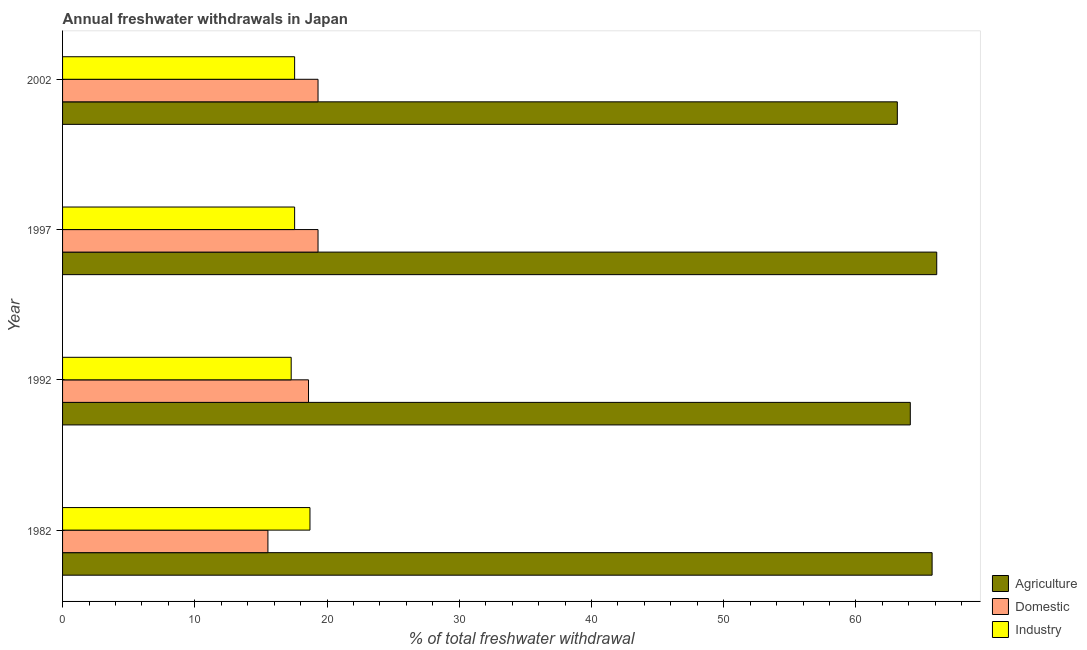How many different coloured bars are there?
Offer a very short reply. 3. How many groups of bars are there?
Your response must be concise. 4. How many bars are there on the 2nd tick from the bottom?
Ensure brevity in your answer.  3. What is the label of the 3rd group of bars from the top?
Provide a short and direct response. 1992. In how many cases, is the number of bars for a given year not equal to the number of legend labels?
Offer a terse response. 0. What is the percentage of freshwater withdrawal for domestic purposes in 2002?
Your response must be concise. 19.32. Across all years, what is the maximum percentage of freshwater withdrawal for domestic purposes?
Your answer should be compact. 19.32. Across all years, what is the minimum percentage of freshwater withdrawal for agriculture?
Ensure brevity in your answer.  63.13. In which year was the percentage of freshwater withdrawal for domestic purposes maximum?
Ensure brevity in your answer.  1997. In which year was the percentage of freshwater withdrawal for agriculture minimum?
Your answer should be compact. 2002. What is the total percentage of freshwater withdrawal for agriculture in the graph?
Keep it short and to the point. 259.11. What is the difference between the percentage of freshwater withdrawal for domestic purposes in 1982 and that in 1997?
Provide a short and direct response. -3.79. What is the difference between the percentage of freshwater withdrawal for domestic purposes in 1992 and the percentage of freshwater withdrawal for industry in 2002?
Provide a short and direct response. 1.05. What is the average percentage of freshwater withdrawal for industry per year?
Offer a very short reply. 17.77. In the year 1997, what is the difference between the percentage of freshwater withdrawal for domestic purposes and percentage of freshwater withdrawal for agriculture?
Give a very brief answer. -46.79. In how many years, is the percentage of freshwater withdrawal for industry greater than 60 %?
Make the answer very short. 0. What is the ratio of the percentage of freshwater withdrawal for domestic purposes in 1992 to that in 2002?
Offer a terse response. 0.96. Is the difference between the percentage of freshwater withdrawal for agriculture in 1992 and 2002 greater than the difference between the percentage of freshwater withdrawal for industry in 1992 and 2002?
Your answer should be very brief. Yes. What is the difference between the highest and the second highest percentage of freshwater withdrawal for domestic purposes?
Offer a terse response. 0. What is the difference between the highest and the lowest percentage of freshwater withdrawal for industry?
Your answer should be very brief. 1.42. In how many years, is the percentage of freshwater withdrawal for agriculture greater than the average percentage of freshwater withdrawal for agriculture taken over all years?
Your response must be concise. 2. What does the 3rd bar from the top in 1982 represents?
Offer a terse response. Agriculture. What does the 2nd bar from the bottom in 1982 represents?
Your answer should be compact. Domestic. How many bars are there?
Make the answer very short. 12. How many years are there in the graph?
Keep it short and to the point. 4. Are the values on the major ticks of X-axis written in scientific E-notation?
Your answer should be very brief. No. What is the title of the graph?
Provide a short and direct response. Annual freshwater withdrawals in Japan. What is the label or title of the X-axis?
Offer a very short reply. % of total freshwater withdrawal. What is the label or title of the Y-axis?
Your response must be concise. Year. What is the % of total freshwater withdrawal in Agriculture in 1982?
Make the answer very short. 65.76. What is the % of total freshwater withdrawal in Domestic in 1982?
Your answer should be very brief. 15.53. What is the % of total freshwater withdrawal in Industry in 1982?
Offer a terse response. 18.71. What is the % of total freshwater withdrawal of Agriculture in 1992?
Offer a terse response. 64.11. What is the % of total freshwater withdrawal of Domestic in 1992?
Keep it short and to the point. 18.6. What is the % of total freshwater withdrawal in Industry in 1992?
Your answer should be compact. 17.29. What is the % of total freshwater withdrawal of Agriculture in 1997?
Provide a short and direct response. 66.11. What is the % of total freshwater withdrawal in Domestic in 1997?
Offer a very short reply. 19.32. What is the % of total freshwater withdrawal in Industry in 1997?
Make the answer very short. 17.55. What is the % of total freshwater withdrawal in Agriculture in 2002?
Offer a terse response. 63.13. What is the % of total freshwater withdrawal of Domestic in 2002?
Keep it short and to the point. 19.32. What is the % of total freshwater withdrawal in Industry in 2002?
Your response must be concise. 17.55. Across all years, what is the maximum % of total freshwater withdrawal of Agriculture?
Offer a very short reply. 66.11. Across all years, what is the maximum % of total freshwater withdrawal of Domestic?
Provide a succinct answer. 19.32. Across all years, what is the maximum % of total freshwater withdrawal of Industry?
Keep it short and to the point. 18.71. Across all years, what is the minimum % of total freshwater withdrawal in Agriculture?
Give a very brief answer. 63.13. Across all years, what is the minimum % of total freshwater withdrawal in Domestic?
Keep it short and to the point. 15.53. Across all years, what is the minimum % of total freshwater withdrawal in Industry?
Offer a very short reply. 17.29. What is the total % of total freshwater withdrawal in Agriculture in the graph?
Your answer should be compact. 259.11. What is the total % of total freshwater withdrawal in Domestic in the graph?
Keep it short and to the point. 72.77. What is the total % of total freshwater withdrawal in Industry in the graph?
Provide a short and direct response. 71.1. What is the difference between the % of total freshwater withdrawal in Agriculture in 1982 and that in 1992?
Provide a succinct answer. 1.65. What is the difference between the % of total freshwater withdrawal of Domestic in 1982 and that in 1992?
Provide a succinct answer. -3.07. What is the difference between the % of total freshwater withdrawal of Industry in 1982 and that in 1992?
Your answer should be compact. 1.42. What is the difference between the % of total freshwater withdrawal of Agriculture in 1982 and that in 1997?
Make the answer very short. -0.35. What is the difference between the % of total freshwater withdrawal in Domestic in 1982 and that in 1997?
Provide a short and direct response. -3.79. What is the difference between the % of total freshwater withdrawal in Industry in 1982 and that in 1997?
Your response must be concise. 1.16. What is the difference between the % of total freshwater withdrawal of Agriculture in 1982 and that in 2002?
Ensure brevity in your answer.  2.63. What is the difference between the % of total freshwater withdrawal in Domestic in 1982 and that in 2002?
Offer a terse response. -3.79. What is the difference between the % of total freshwater withdrawal of Industry in 1982 and that in 2002?
Provide a short and direct response. 1.16. What is the difference between the % of total freshwater withdrawal in Domestic in 1992 and that in 1997?
Your response must be concise. -0.72. What is the difference between the % of total freshwater withdrawal of Industry in 1992 and that in 1997?
Offer a terse response. -0.26. What is the difference between the % of total freshwater withdrawal in Agriculture in 1992 and that in 2002?
Keep it short and to the point. 0.98. What is the difference between the % of total freshwater withdrawal in Domestic in 1992 and that in 2002?
Your answer should be compact. -0.72. What is the difference between the % of total freshwater withdrawal in Industry in 1992 and that in 2002?
Your response must be concise. -0.26. What is the difference between the % of total freshwater withdrawal in Agriculture in 1997 and that in 2002?
Your answer should be compact. 2.98. What is the difference between the % of total freshwater withdrawal in Domestic in 1997 and that in 2002?
Give a very brief answer. 0. What is the difference between the % of total freshwater withdrawal in Industry in 1997 and that in 2002?
Your answer should be compact. 0. What is the difference between the % of total freshwater withdrawal of Agriculture in 1982 and the % of total freshwater withdrawal of Domestic in 1992?
Provide a short and direct response. 47.16. What is the difference between the % of total freshwater withdrawal in Agriculture in 1982 and the % of total freshwater withdrawal in Industry in 1992?
Ensure brevity in your answer.  48.47. What is the difference between the % of total freshwater withdrawal in Domestic in 1982 and the % of total freshwater withdrawal in Industry in 1992?
Give a very brief answer. -1.76. What is the difference between the % of total freshwater withdrawal in Agriculture in 1982 and the % of total freshwater withdrawal in Domestic in 1997?
Give a very brief answer. 46.44. What is the difference between the % of total freshwater withdrawal of Agriculture in 1982 and the % of total freshwater withdrawal of Industry in 1997?
Make the answer very short. 48.21. What is the difference between the % of total freshwater withdrawal of Domestic in 1982 and the % of total freshwater withdrawal of Industry in 1997?
Provide a succinct answer. -2.02. What is the difference between the % of total freshwater withdrawal of Agriculture in 1982 and the % of total freshwater withdrawal of Domestic in 2002?
Provide a short and direct response. 46.44. What is the difference between the % of total freshwater withdrawal in Agriculture in 1982 and the % of total freshwater withdrawal in Industry in 2002?
Your response must be concise. 48.21. What is the difference between the % of total freshwater withdrawal of Domestic in 1982 and the % of total freshwater withdrawal of Industry in 2002?
Offer a very short reply. -2.02. What is the difference between the % of total freshwater withdrawal of Agriculture in 1992 and the % of total freshwater withdrawal of Domestic in 1997?
Provide a succinct answer. 44.79. What is the difference between the % of total freshwater withdrawal in Agriculture in 1992 and the % of total freshwater withdrawal in Industry in 1997?
Ensure brevity in your answer.  46.56. What is the difference between the % of total freshwater withdrawal in Agriculture in 1992 and the % of total freshwater withdrawal in Domestic in 2002?
Ensure brevity in your answer.  44.79. What is the difference between the % of total freshwater withdrawal of Agriculture in 1992 and the % of total freshwater withdrawal of Industry in 2002?
Provide a short and direct response. 46.56. What is the difference between the % of total freshwater withdrawal in Domestic in 1992 and the % of total freshwater withdrawal in Industry in 2002?
Make the answer very short. 1.05. What is the difference between the % of total freshwater withdrawal in Agriculture in 1997 and the % of total freshwater withdrawal in Domestic in 2002?
Your response must be concise. 46.79. What is the difference between the % of total freshwater withdrawal in Agriculture in 1997 and the % of total freshwater withdrawal in Industry in 2002?
Your answer should be very brief. 48.56. What is the difference between the % of total freshwater withdrawal of Domestic in 1997 and the % of total freshwater withdrawal of Industry in 2002?
Give a very brief answer. 1.77. What is the average % of total freshwater withdrawal in Agriculture per year?
Your response must be concise. 64.78. What is the average % of total freshwater withdrawal of Domestic per year?
Keep it short and to the point. 18.19. What is the average % of total freshwater withdrawal in Industry per year?
Offer a terse response. 17.77. In the year 1982, what is the difference between the % of total freshwater withdrawal of Agriculture and % of total freshwater withdrawal of Domestic?
Offer a very short reply. 50.23. In the year 1982, what is the difference between the % of total freshwater withdrawal in Agriculture and % of total freshwater withdrawal in Industry?
Ensure brevity in your answer.  47.05. In the year 1982, what is the difference between the % of total freshwater withdrawal of Domestic and % of total freshwater withdrawal of Industry?
Provide a short and direct response. -3.18. In the year 1992, what is the difference between the % of total freshwater withdrawal of Agriculture and % of total freshwater withdrawal of Domestic?
Your answer should be compact. 45.51. In the year 1992, what is the difference between the % of total freshwater withdrawal of Agriculture and % of total freshwater withdrawal of Industry?
Give a very brief answer. 46.82. In the year 1992, what is the difference between the % of total freshwater withdrawal in Domestic and % of total freshwater withdrawal in Industry?
Your answer should be very brief. 1.31. In the year 1997, what is the difference between the % of total freshwater withdrawal in Agriculture and % of total freshwater withdrawal in Domestic?
Make the answer very short. 46.79. In the year 1997, what is the difference between the % of total freshwater withdrawal of Agriculture and % of total freshwater withdrawal of Industry?
Offer a very short reply. 48.56. In the year 1997, what is the difference between the % of total freshwater withdrawal in Domestic and % of total freshwater withdrawal in Industry?
Provide a short and direct response. 1.77. In the year 2002, what is the difference between the % of total freshwater withdrawal of Agriculture and % of total freshwater withdrawal of Domestic?
Provide a succinct answer. 43.81. In the year 2002, what is the difference between the % of total freshwater withdrawal in Agriculture and % of total freshwater withdrawal in Industry?
Offer a very short reply. 45.58. In the year 2002, what is the difference between the % of total freshwater withdrawal in Domestic and % of total freshwater withdrawal in Industry?
Make the answer very short. 1.77. What is the ratio of the % of total freshwater withdrawal in Agriculture in 1982 to that in 1992?
Offer a very short reply. 1.03. What is the ratio of the % of total freshwater withdrawal in Domestic in 1982 to that in 1992?
Your answer should be very brief. 0.83. What is the ratio of the % of total freshwater withdrawal in Industry in 1982 to that in 1992?
Provide a short and direct response. 1.08. What is the ratio of the % of total freshwater withdrawal of Agriculture in 1982 to that in 1997?
Provide a short and direct response. 0.99. What is the ratio of the % of total freshwater withdrawal of Domestic in 1982 to that in 1997?
Offer a very short reply. 0.8. What is the ratio of the % of total freshwater withdrawal of Industry in 1982 to that in 1997?
Keep it short and to the point. 1.07. What is the ratio of the % of total freshwater withdrawal in Agriculture in 1982 to that in 2002?
Make the answer very short. 1.04. What is the ratio of the % of total freshwater withdrawal in Domestic in 1982 to that in 2002?
Provide a short and direct response. 0.8. What is the ratio of the % of total freshwater withdrawal of Industry in 1982 to that in 2002?
Make the answer very short. 1.07. What is the ratio of the % of total freshwater withdrawal of Agriculture in 1992 to that in 1997?
Provide a succinct answer. 0.97. What is the ratio of the % of total freshwater withdrawal in Domestic in 1992 to that in 1997?
Offer a terse response. 0.96. What is the ratio of the % of total freshwater withdrawal of Industry in 1992 to that in 1997?
Your response must be concise. 0.99. What is the ratio of the % of total freshwater withdrawal in Agriculture in 1992 to that in 2002?
Your answer should be compact. 1.02. What is the ratio of the % of total freshwater withdrawal of Domestic in 1992 to that in 2002?
Your answer should be compact. 0.96. What is the ratio of the % of total freshwater withdrawal of Industry in 1992 to that in 2002?
Your answer should be compact. 0.99. What is the ratio of the % of total freshwater withdrawal of Agriculture in 1997 to that in 2002?
Keep it short and to the point. 1.05. What is the ratio of the % of total freshwater withdrawal of Domestic in 1997 to that in 2002?
Offer a very short reply. 1. What is the ratio of the % of total freshwater withdrawal in Industry in 1997 to that in 2002?
Make the answer very short. 1. What is the difference between the highest and the second highest % of total freshwater withdrawal in Industry?
Your response must be concise. 1.16. What is the difference between the highest and the lowest % of total freshwater withdrawal of Agriculture?
Offer a terse response. 2.98. What is the difference between the highest and the lowest % of total freshwater withdrawal in Domestic?
Make the answer very short. 3.79. What is the difference between the highest and the lowest % of total freshwater withdrawal of Industry?
Your answer should be very brief. 1.42. 